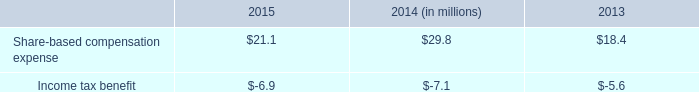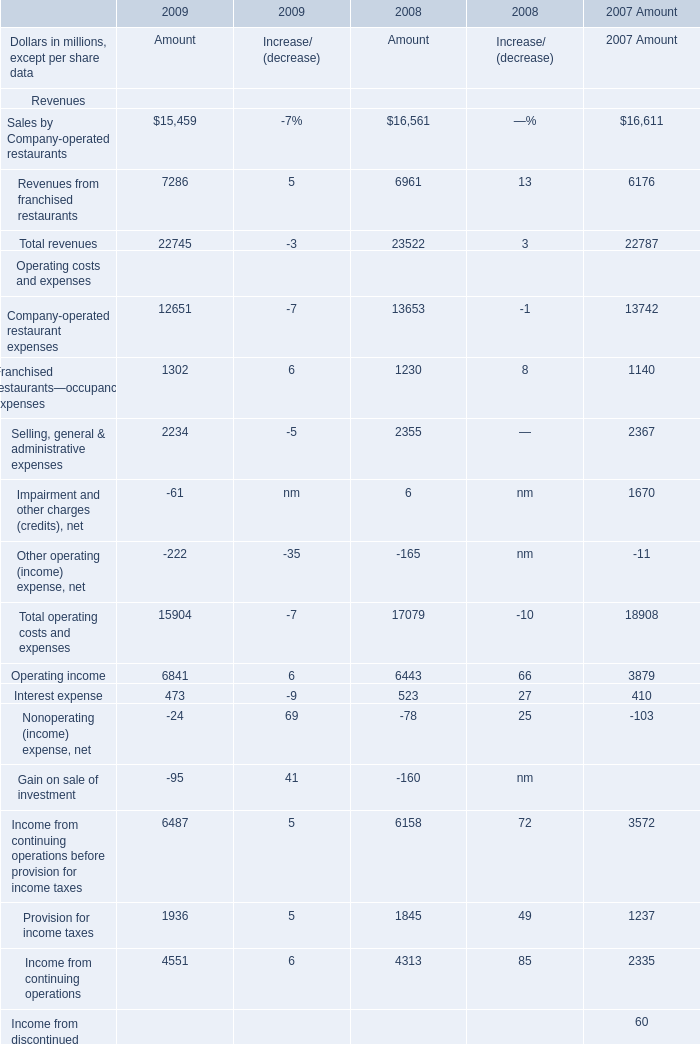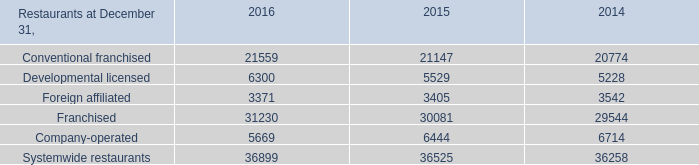What is the growing rate of Company-operated restaurant expenses in the years with the least Sales by Company-operated restaurants? 
Computations: ((12651 - 13653) / 13653)
Answer: -0.07339. 